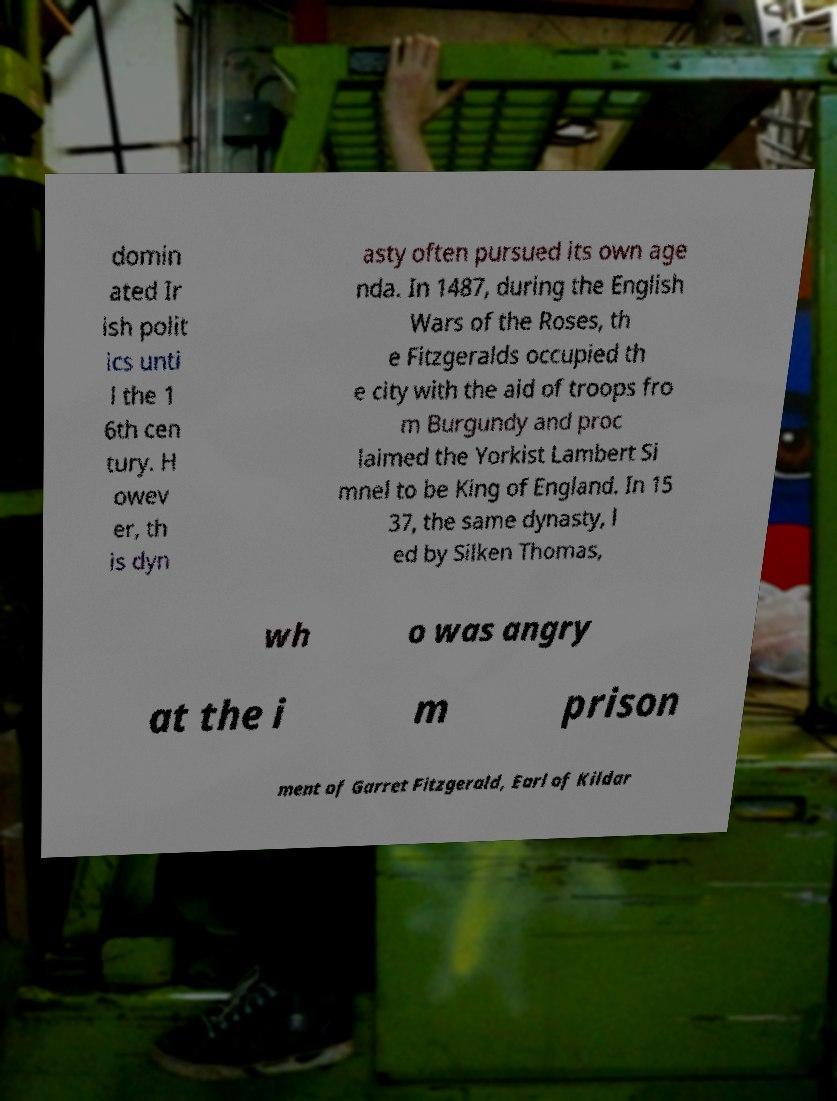Please read and relay the text visible in this image. What does it say? domin ated Ir ish polit ics unti l the 1 6th cen tury. H owev er, th is dyn asty often pursued its own age nda. In 1487, during the English Wars of the Roses, th e Fitzgeralds occupied th e city with the aid of troops fro m Burgundy and proc laimed the Yorkist Lambert Si mnel to be King of England. In 15 37, the same dynasty, l ed by Silken Thomas, wh o was angry at the i m prison ment of Garret Fitzgerald, Earl of Kildar 